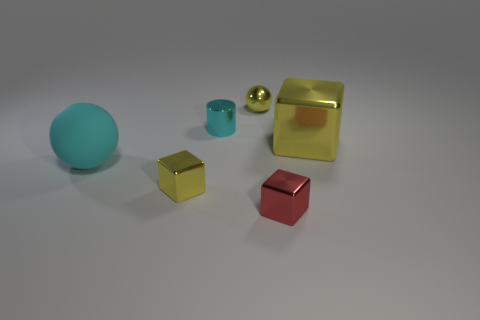Subtract all blue cylinders. Subtract all brown spheres. How many cylinders are left? 1 Add 1 small yellow blocks. How many objects exist? 7 Subtract all cylinders. How many objects are left? 5 Add 6 small red shiny cubes. How many small red shiny cubes are left? 7 Add 3 rubber cubes. How many rubber cubes exist? 3 Subtract 0 red cylinders. How many objects are left? 6 Subtract all big matte cylinders. Subtract all tiny yellow objects. How many objects are left? 4 